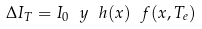Convert formula to latex. <formula><loc_0><loc_0><loc_500><loc_500>\Delta I _ { T } = I _ { 0 } \ y \ h ( x ) \ f ( x , T _ { e } )</formula> 